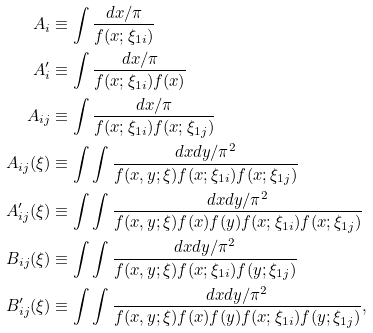<formula> <loc_0><loc_0><loc_500><loc_500>A _ { i } & \equiv \int \frac { d x / \pi } { f ( x ; \xi _ { 1 i } ) } \\ A ^ { \prime } _ { i } & \equiv \int \frac { d x / \pi } { f ( x ; \xi _ { 1 i } ) f ( x ) } \\ A _ { i j } & \equiv \int \frac { d x / \pi } { f ( x ; \xi _ { 1 i } ) f ( x ; \xi _ { 1 j } ) } \\ A _ { i j } ( \xi ) & \equiv \int \int \frac { d x d y / \pi ^ { 2 } } { f ( x , y ; \xi ) f ( x ; \xi _ { 1 i } ) f ( x ; \xi _ { 1 j } ) } \\ A ^ { \prime } _ { i j } ( \xi ) & \equiv \int \int \frac { d x d y / \pi ^ { 2 } } { f ( x , y ; \xi ) f ( x ) f ( y ) f ( x ; \xi _ { 1 i } ) f ( x ; \xi _ { 1 j } ) } \\ B _ { i j } ( \xi ) & \equiv \int \int \frac { d x d y / \pi ^ { 2 } } { f ( x , y ; \xi ) f ( x ; \xi _ { 1 i } ) f ( y ; \xi _ { 1 j } ) } \\ B ^ { \prime } _ { i j } ( \xi ) & \equiv \int \int \frac { d x d y / \pi ^ { 2 } } { f ( x , y ; \xi ) f ( x ) f ( y ) f ( x ; \xi _ { 1 i } ) f ( y ; \xi _ { 1 j } ) } ,</formula> 